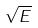<formula> <loc_0><loc_0><loc_500><loc_500>\sqrt { E }</formula> 